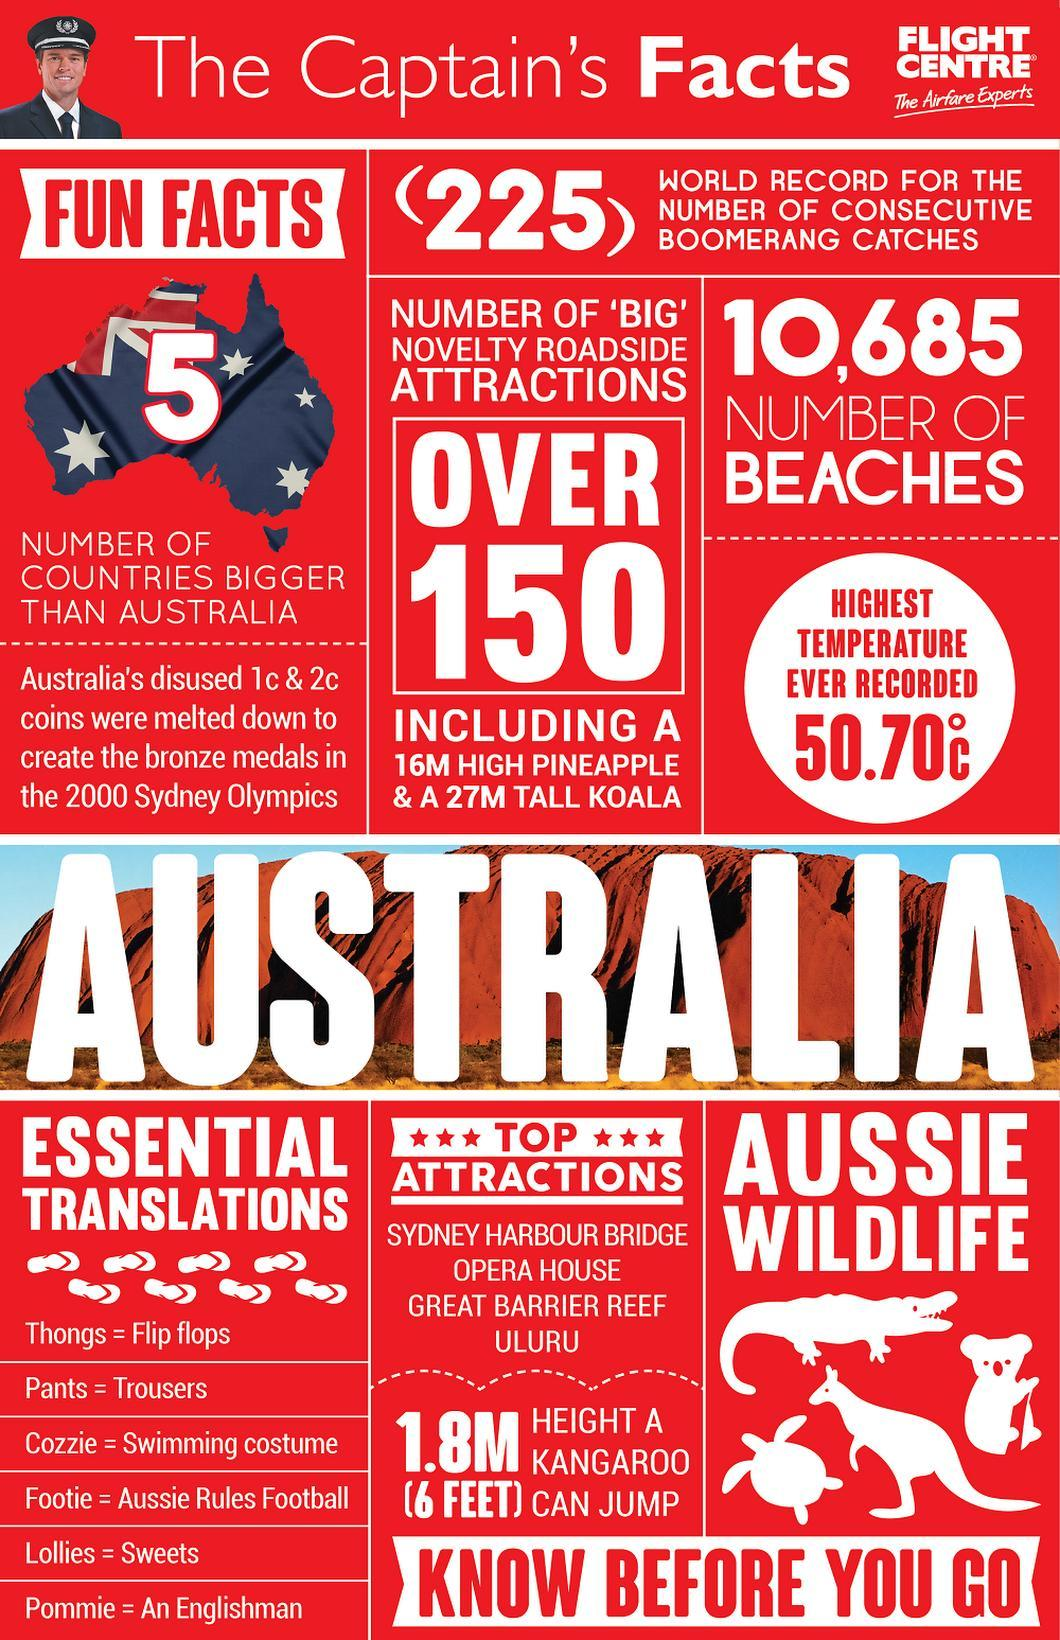which is the second top attraction shown
Answer the question with a short phrase. opera house what does the count 10,685 represent beaches what is the height difference between pineapple and koala 11 how many countries are bigger than australia 5 what were melted down to create bronze medals australias's disused 1c & 2c coins how many stars are shown on either side of TOP 6 how many wildlife pictures are shown in the document 4 6 feet is equal to how many metres 1.8 